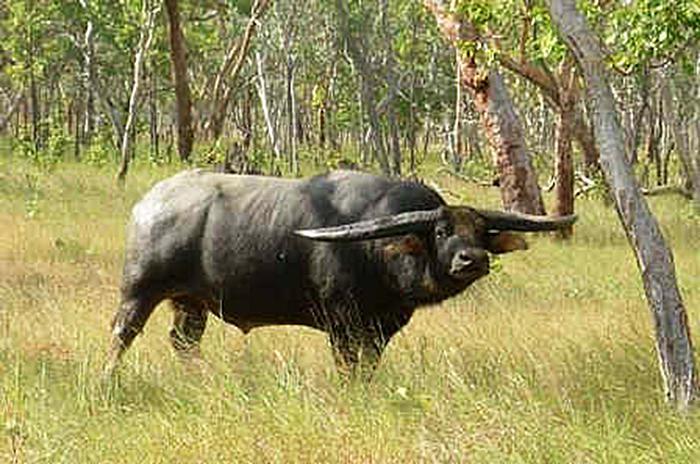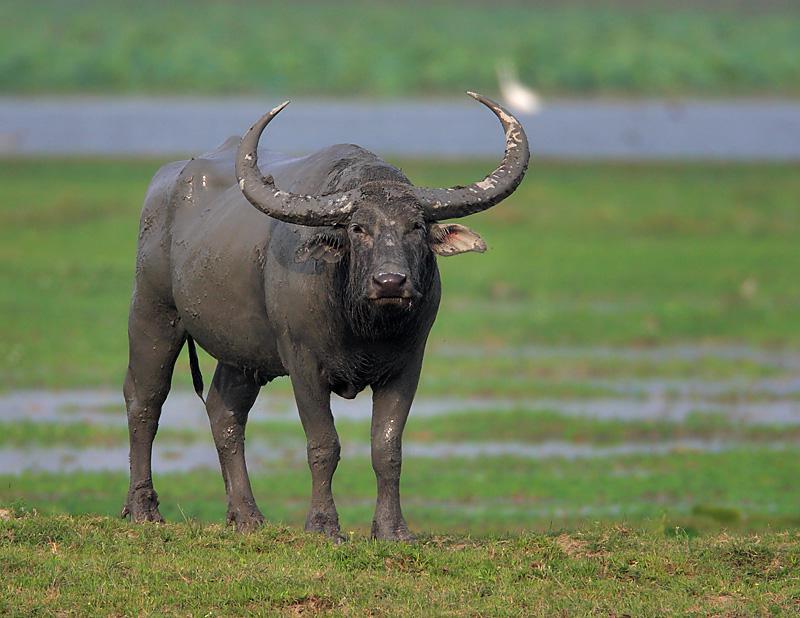The first image is the image on the left, the second image is the image on the right. Assess this claim about the two images: "There are exactly two water buffalos with one of them facing leftward.". Correct or not? Answer yes or no. No. The first image is the image on the left, the second image is the image on the right. For the images displayed, is the sentence "In at least one image,there is a single black bull with two long horns facing left on grass and dirt." factually correct? Answer yes or no. No. 